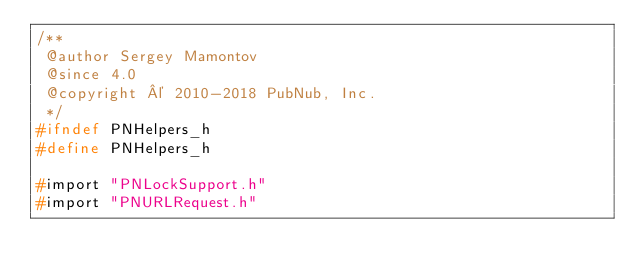Convert code to text. <code><loc_0><loc_0><loc_500><loc_500><_C_>/**
 @author Sergey Mamontov
 @since 4.0
 @copyright © 2010-2018 PubNub, Inc.
 */
#ifndef PNHelpers_h
#define PNHelpers_h

#import "PNLockSupport.h"
#import "PNURLRequest.h"</code> 